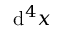<formula> <loc_0><loc_0><loc_500><loc_500>d ^ { 4 } x</formula> 